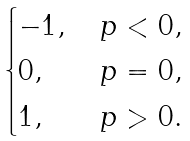<formula> <loc_0><loc_0><loc_500><loc_500>\begin{cases} - 1 , \, & p < 0 , \\ 0 , \, & p = 0 , \\ 1 , \, & p > 0 . \end{cases}</formula> 